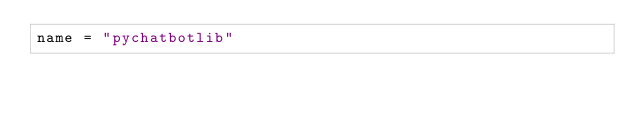Convert code to text. <code><loc_0><loc_0><loc_500><loc_500><_Python_>name = "pychatbotlib"</code> 